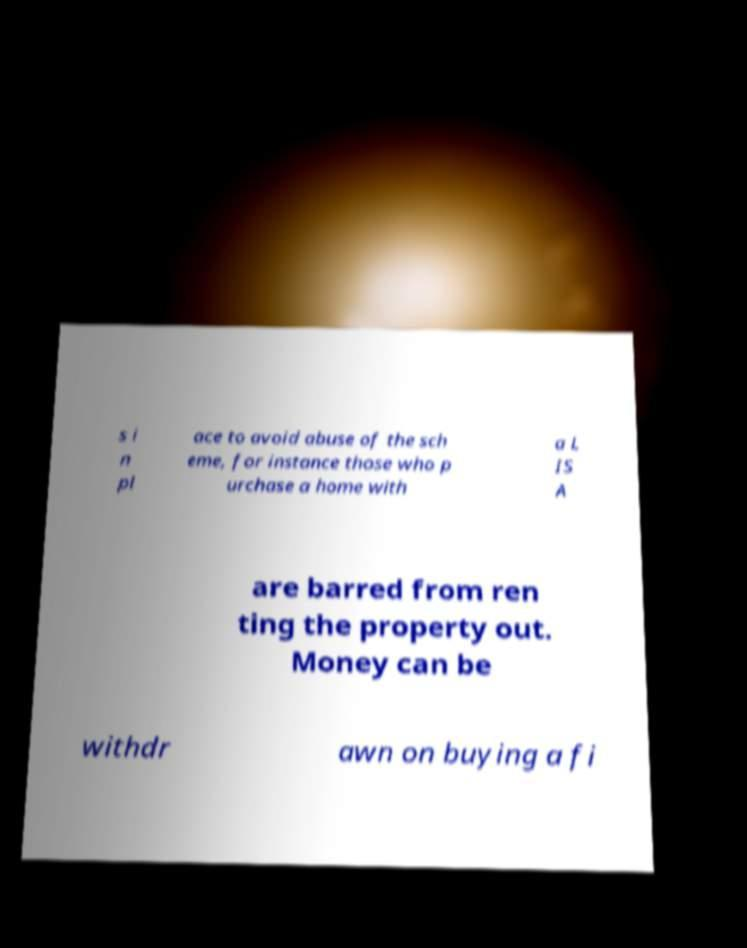Please read and relay the text visible in this image. What does it say? s i n pl ace to avoid abuse of the sch eme, for instance those who p urchase a home with a L IS A are barred from ren ting the property out. Money can be withdr awn on buying a fi 